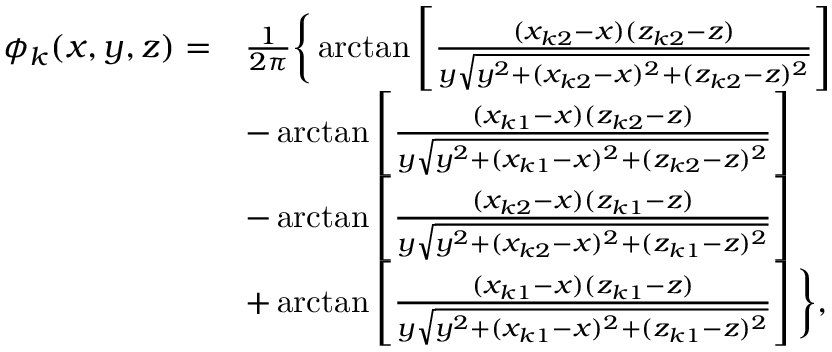Convert formula to latex. <formula><loc_0><loc_0><loc_500><loc_500>\begin{array} { r l } { \phi _ { k } ( x , y , z ) = } & { \frac { 1 } { 2 \pi } \left \{ \arctan \left [ \frac { ( x _ { k 2 } - x ) ( z _ { k 2 } - z ) } { y \sqrt { y ^ { 2 } + ( x _ { k 2 } - x ) ^ { 2 } + ( z _ { k 2 } - z ) ^ { 2 } } } \right ] } \\ & { - \arctan \left [ \frac { ( x _ { k 1 } - x ) ( z _ { k 2 } - z ) } { y \sqrt { y ^ { 2 } + ( x _ { k 1 } - x ) ^ { 2 } + ( z _ { k 2 } - z ) ^ { 2 } } } \right ] } \\ & { - \arctan \left [ \frac { ( x _ { k 2 } - x ) ( z _ { k 1 } - z ) } { y \sqrt { y ^ { 2 } + ( x _ { k 2 } - x ) ^ { 2 } + ( z _ { k 1 } - z ) ^ { 2 } } } \right ] } \\ & { + \arctan \left [ \frac { ( x _ { k 1 } - x ) ( z _ { k 1 } - z ) } { y \sqrt { y ^ { 2 } + ( x _ { k 1 } - x ) ^ { 2 } + ( z _ { k 1 } - z ) ^ { 2 } } } \right ] \right \} , } \end{array}</formula> 